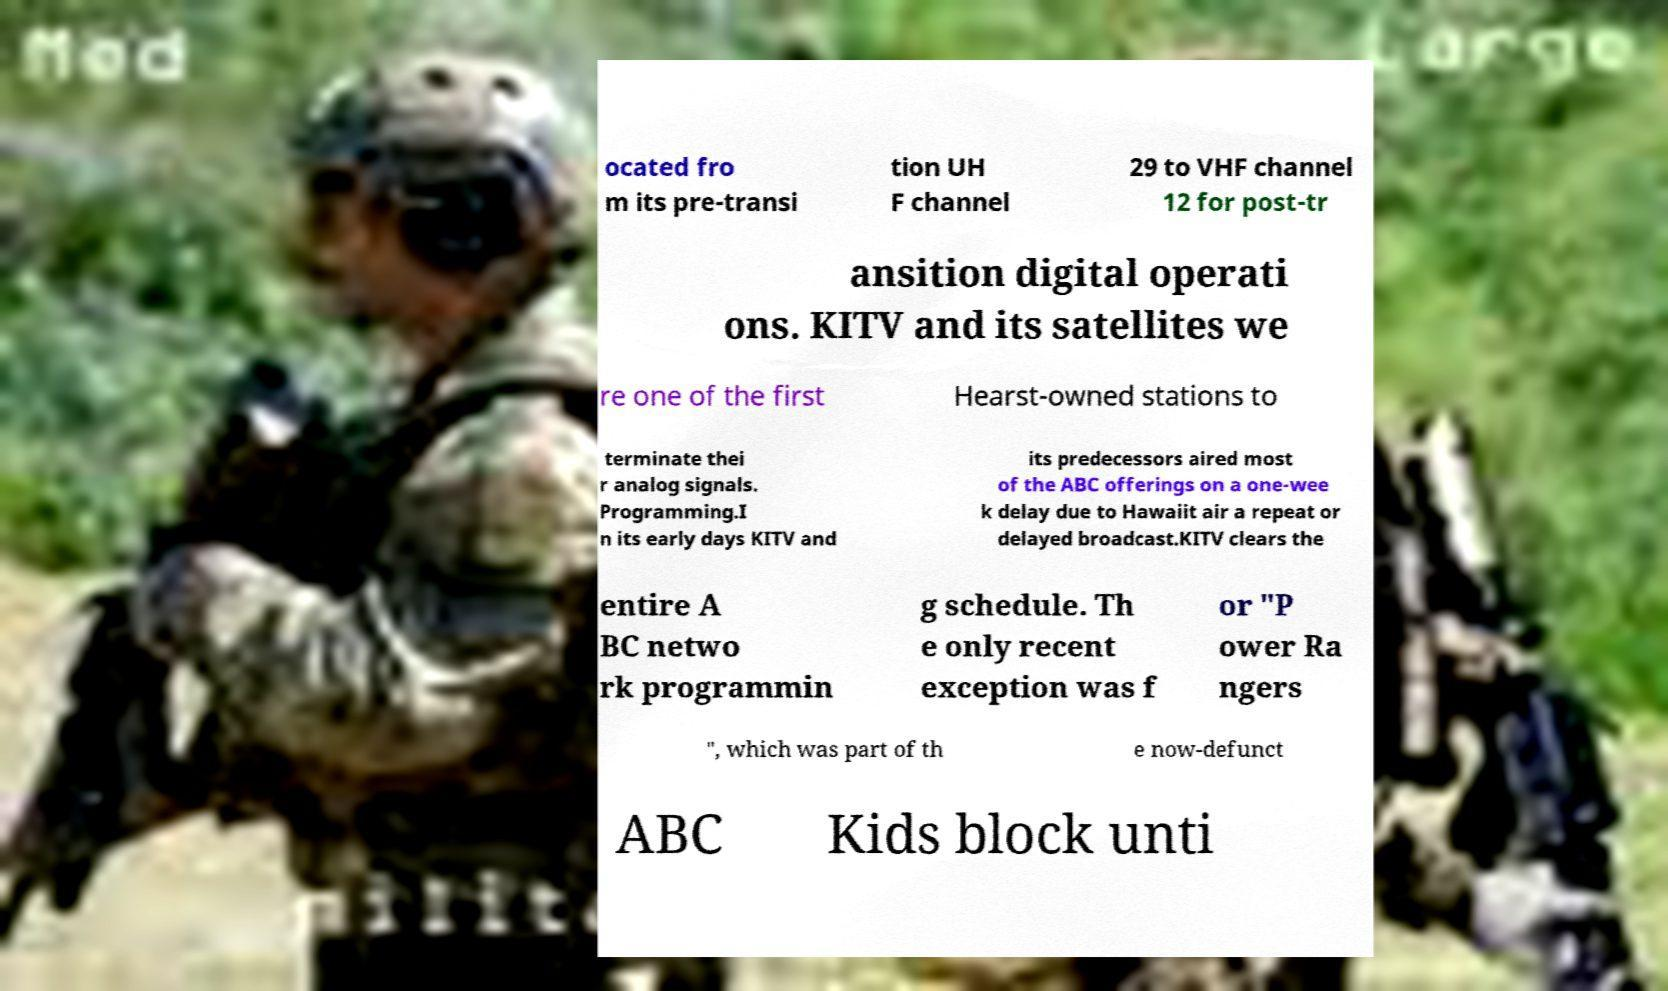I need the written content from this picture converted into text. Can you do that? ocated fro m its pre-transi tion UH F channel 29 to VHF channel 12 for post-tr ansition digital operati ons. KITV and its satellites we re one of the first Hearst-owned stations to terminate thei r analog signals. Programming.I n its early days KITV and its predecessors aired most of the ABC offerings on a one-wee k delay due to Hawaiit air a repeat or delayed broadcast.KITV clears the entire A BC netwo rk programmin g schedule. Th e only recent exception was f or "P ower Ra ngers ", which was part of th e now-defunct ABC Kids block unti 